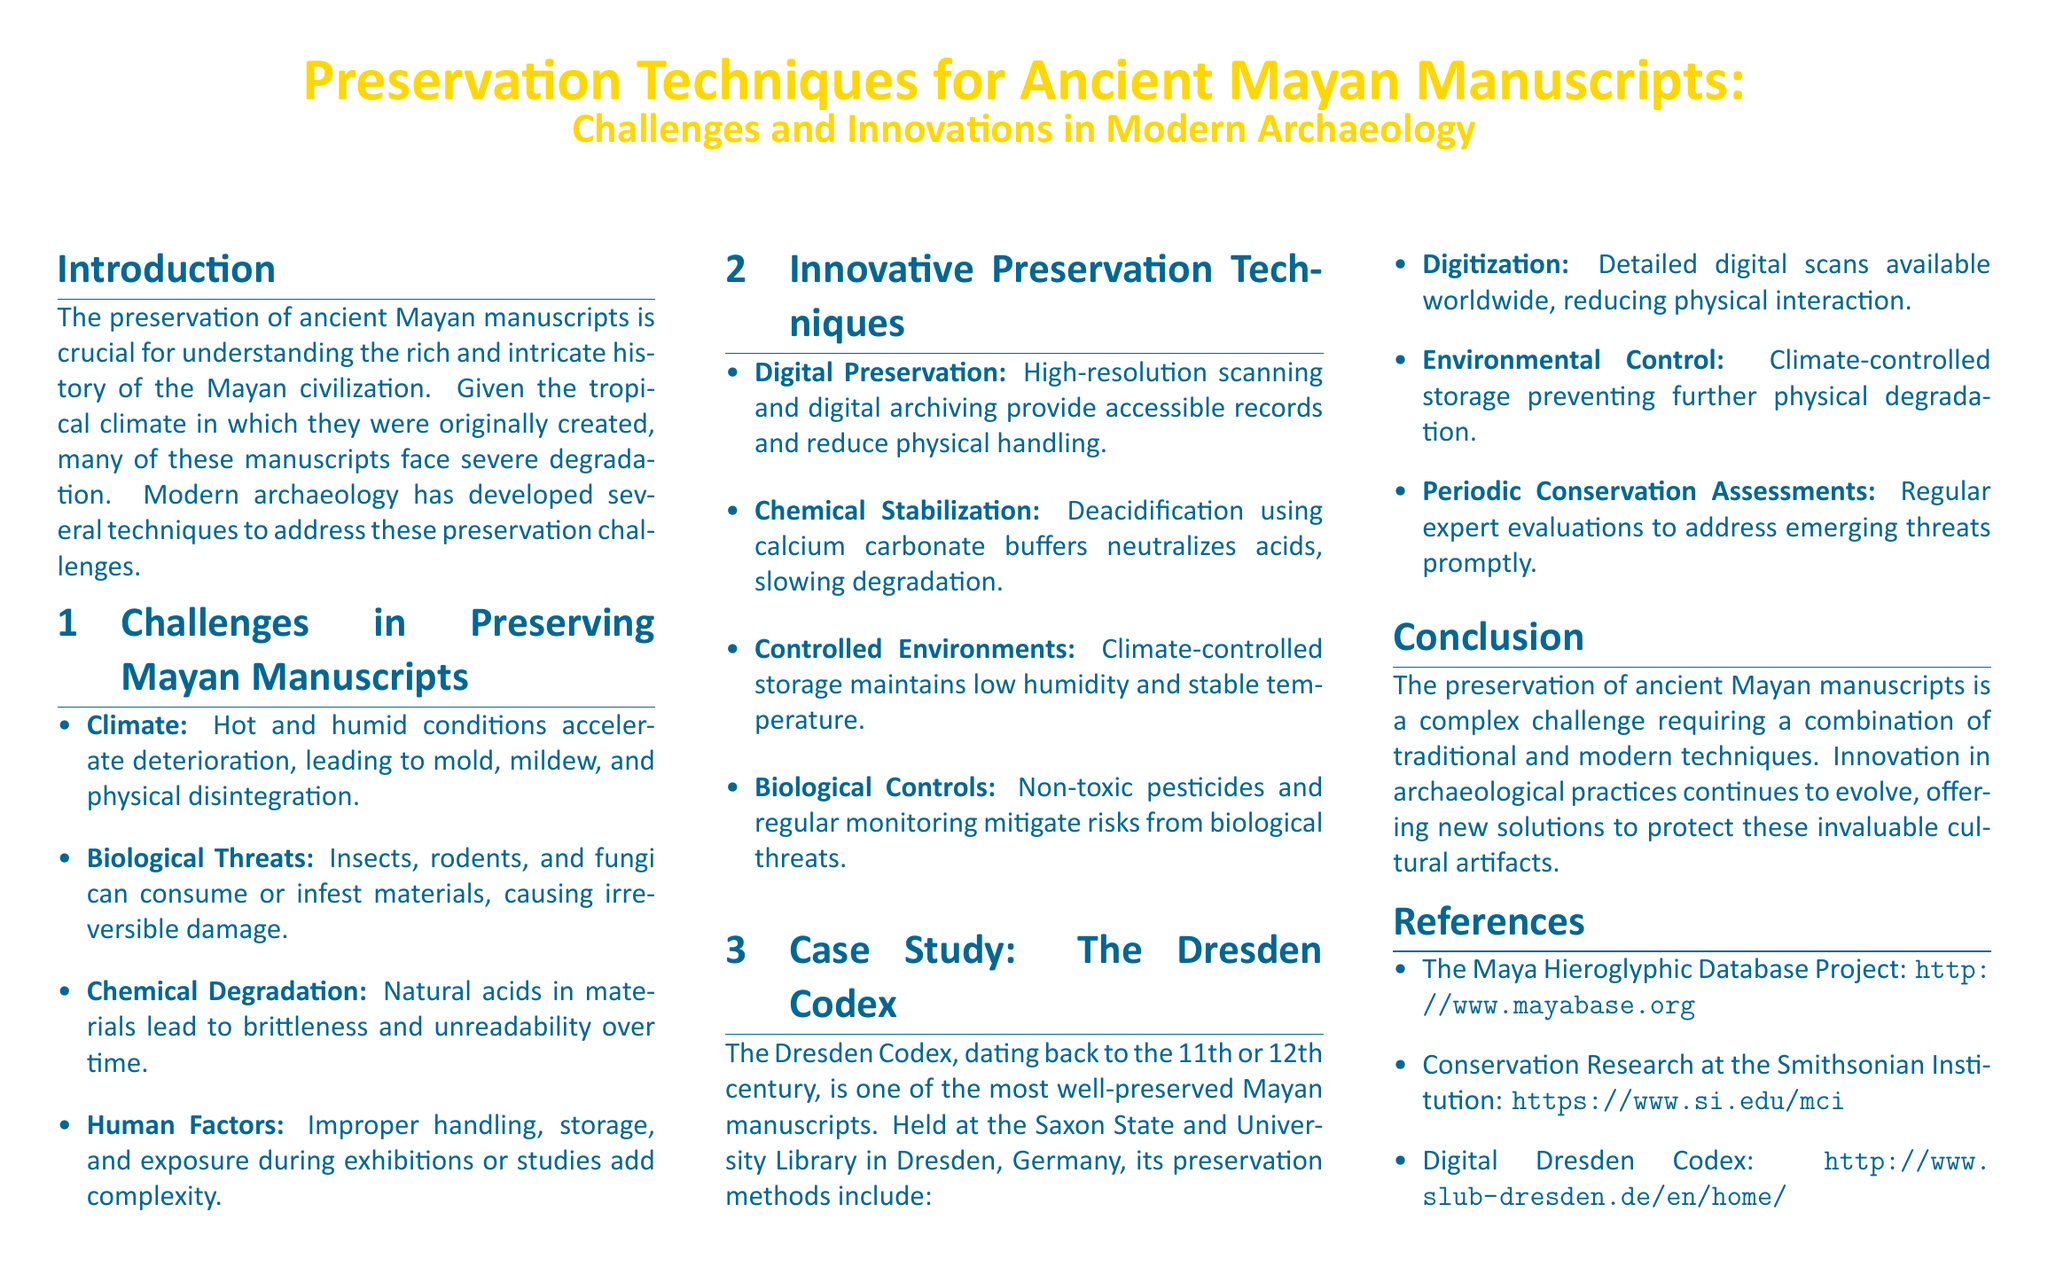What is the preservation focus of the whitepaper? The whitepaper emphasizes the preservation of ancient Mayan manuscripts, detailing the challenges and innovations involved in modern archaeology.
Answer: Ancient Mayan manuscripts What environmental factors accelerate manuscript degradation? The document lists hot and humid conditions as key environmental factors leading to increased deterioration.
Answer: Hot and humid conditions What is one method of digital preservation mentioned? The whitepaper states that high-resolution scanning is one technique used for digital preservation.
Answer: High-resolution scanning What is the purpose of chemical stabilization? Chemical stabilization aims to neutralize acids in materials, thus slowing their degradation.
Answer: To neutralize acids Which ancient manuscript is used as a case study? The whitepaper specifically discusses the Dresden Codex as a case study for preservation methods.
Answer: The Dresden Codex What year is the Dresden Codex believed to date back to? According to the document, the Dresden Codex is dated to either the 11th or 12th century.
Answer: 11th or 12th century What type of control is used to mitigate biological threats? The document refers to the use of non-toxic pesticides as a control measure against biological threats.
Answer: Non-toxic pesticides What regular practice helps maintain the condition of the Dresden Codex? The document mentions periodic conservation assessments as a practice for evaluating the condition of the manuscript.
Answer: Periodic conservation assessments 